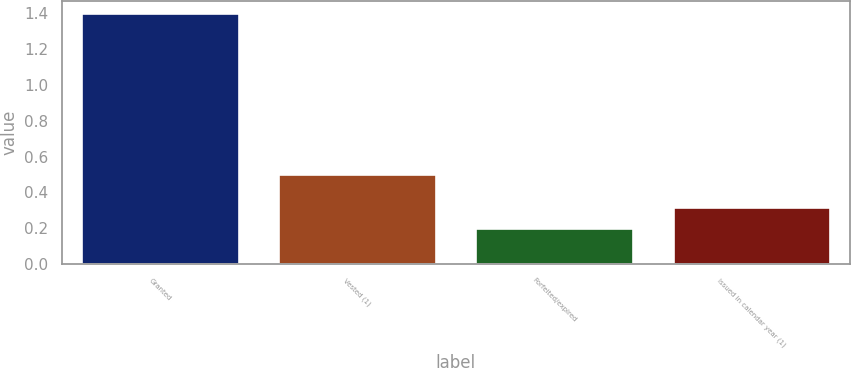Convert chart. <chart><loc_0><loc_0><loc_500><loc_500><bar_chart><fcel>Granted<fcel>Vested (1)<fcel>Forfeited/expired<fcel>Issued in calendar year (1)<nl><fcel>1.4<fcel>0.5<fcel>0.2<fcel>0.32<nl></chart> 